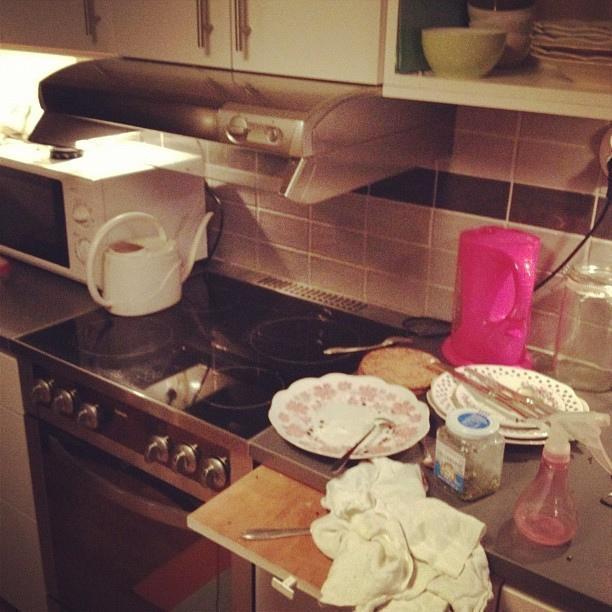How many appliances are there?
Give a very brief answer. 2. How many bottles can you see?
Give a very brief answer. 1. How many microwaves are there?
Give a very brief answer. 1. 